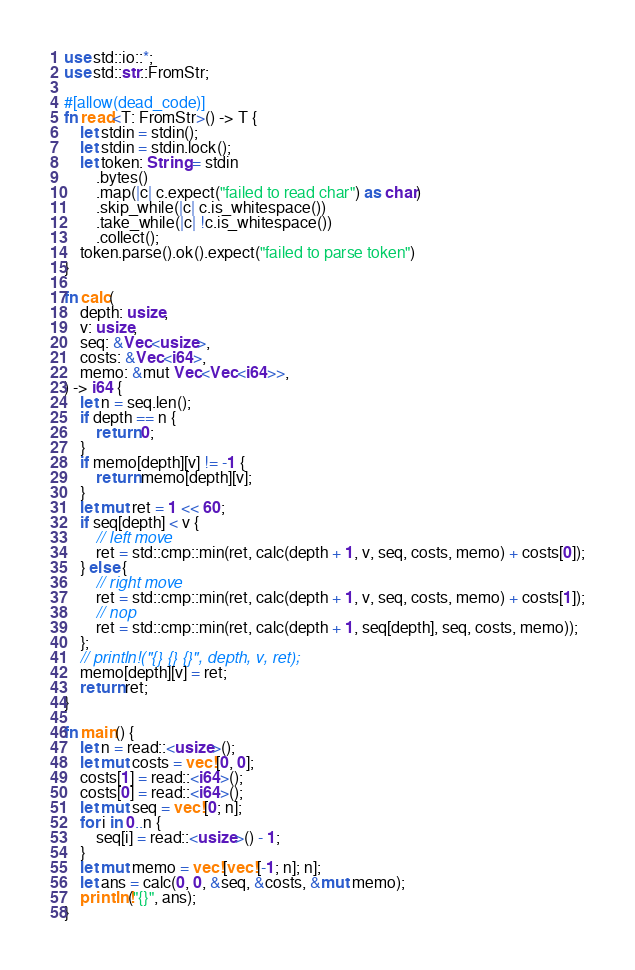Convert code to text. <code><loc_0><loc_0><loc_500><loc_500><_Rust_>use std::io::*;
use std::str::FromStr;

#[allow(dead_code)]
fn read<T: FromStr>() -> T {
    let stdin = stdin();
    let stdin = stdin.lock();
    let token: String = stdin
        .bytes()
        .map(|c| c.expect("failed to read char") as char)
        .skip_while(|c| c.is_whitespace())
        .take_while(|c| !c.is_whitespace())
        .collect();
    token.parse().ok().expect("failed to parse token")
}

fn calc(
    depth: usize,
    v: usize,
    seq: &Vec<usize>,
    costs: &Vec<i64>,
    memo: &mut Vec<Vec<i64>>,
) -> i64 {
    let n = seq.len();
    if depth == n {
        return 0;
    }
    if memo[depth][v] != -1 {
        return memo[depth][v];
    }
    let mut ret = 1 << 60;
    if seq[depth] < v {
        // left move
        ret = std::cmp::min(ret, calc(depth + 1, v, seq, costs, memo) + costs[0]);
    } else {
        // right move
        ret = std::cmp::min(ret, calc(depth + 1, v, seq, costs, memo) + costs[1]);
        // nop
        ret = std::cmp::min(ret, calc(depth + 1, seq[depth], seq, costs, memo));
    };
    // println!("{} {} {}", depth, v, ret);
    memo[depth][v] = ret;
    return ret;
}

fn main() {
    let n = read::<usize>();
    let mut costs = vec![0, 0];
    costs[1] = read::<i64>();
    costs[0] = read::<i64>();
    let mut seq = vec![0; n];
    for i in 0..n {
        seq[i] = read::<usize>() - 1;
    }
    let mut memo = vec![vec![-1; n]; n];
    let ans = calc(0, 0, &seq, &costs, &mut memo);
    println!("{}", ans);
}
</code> 